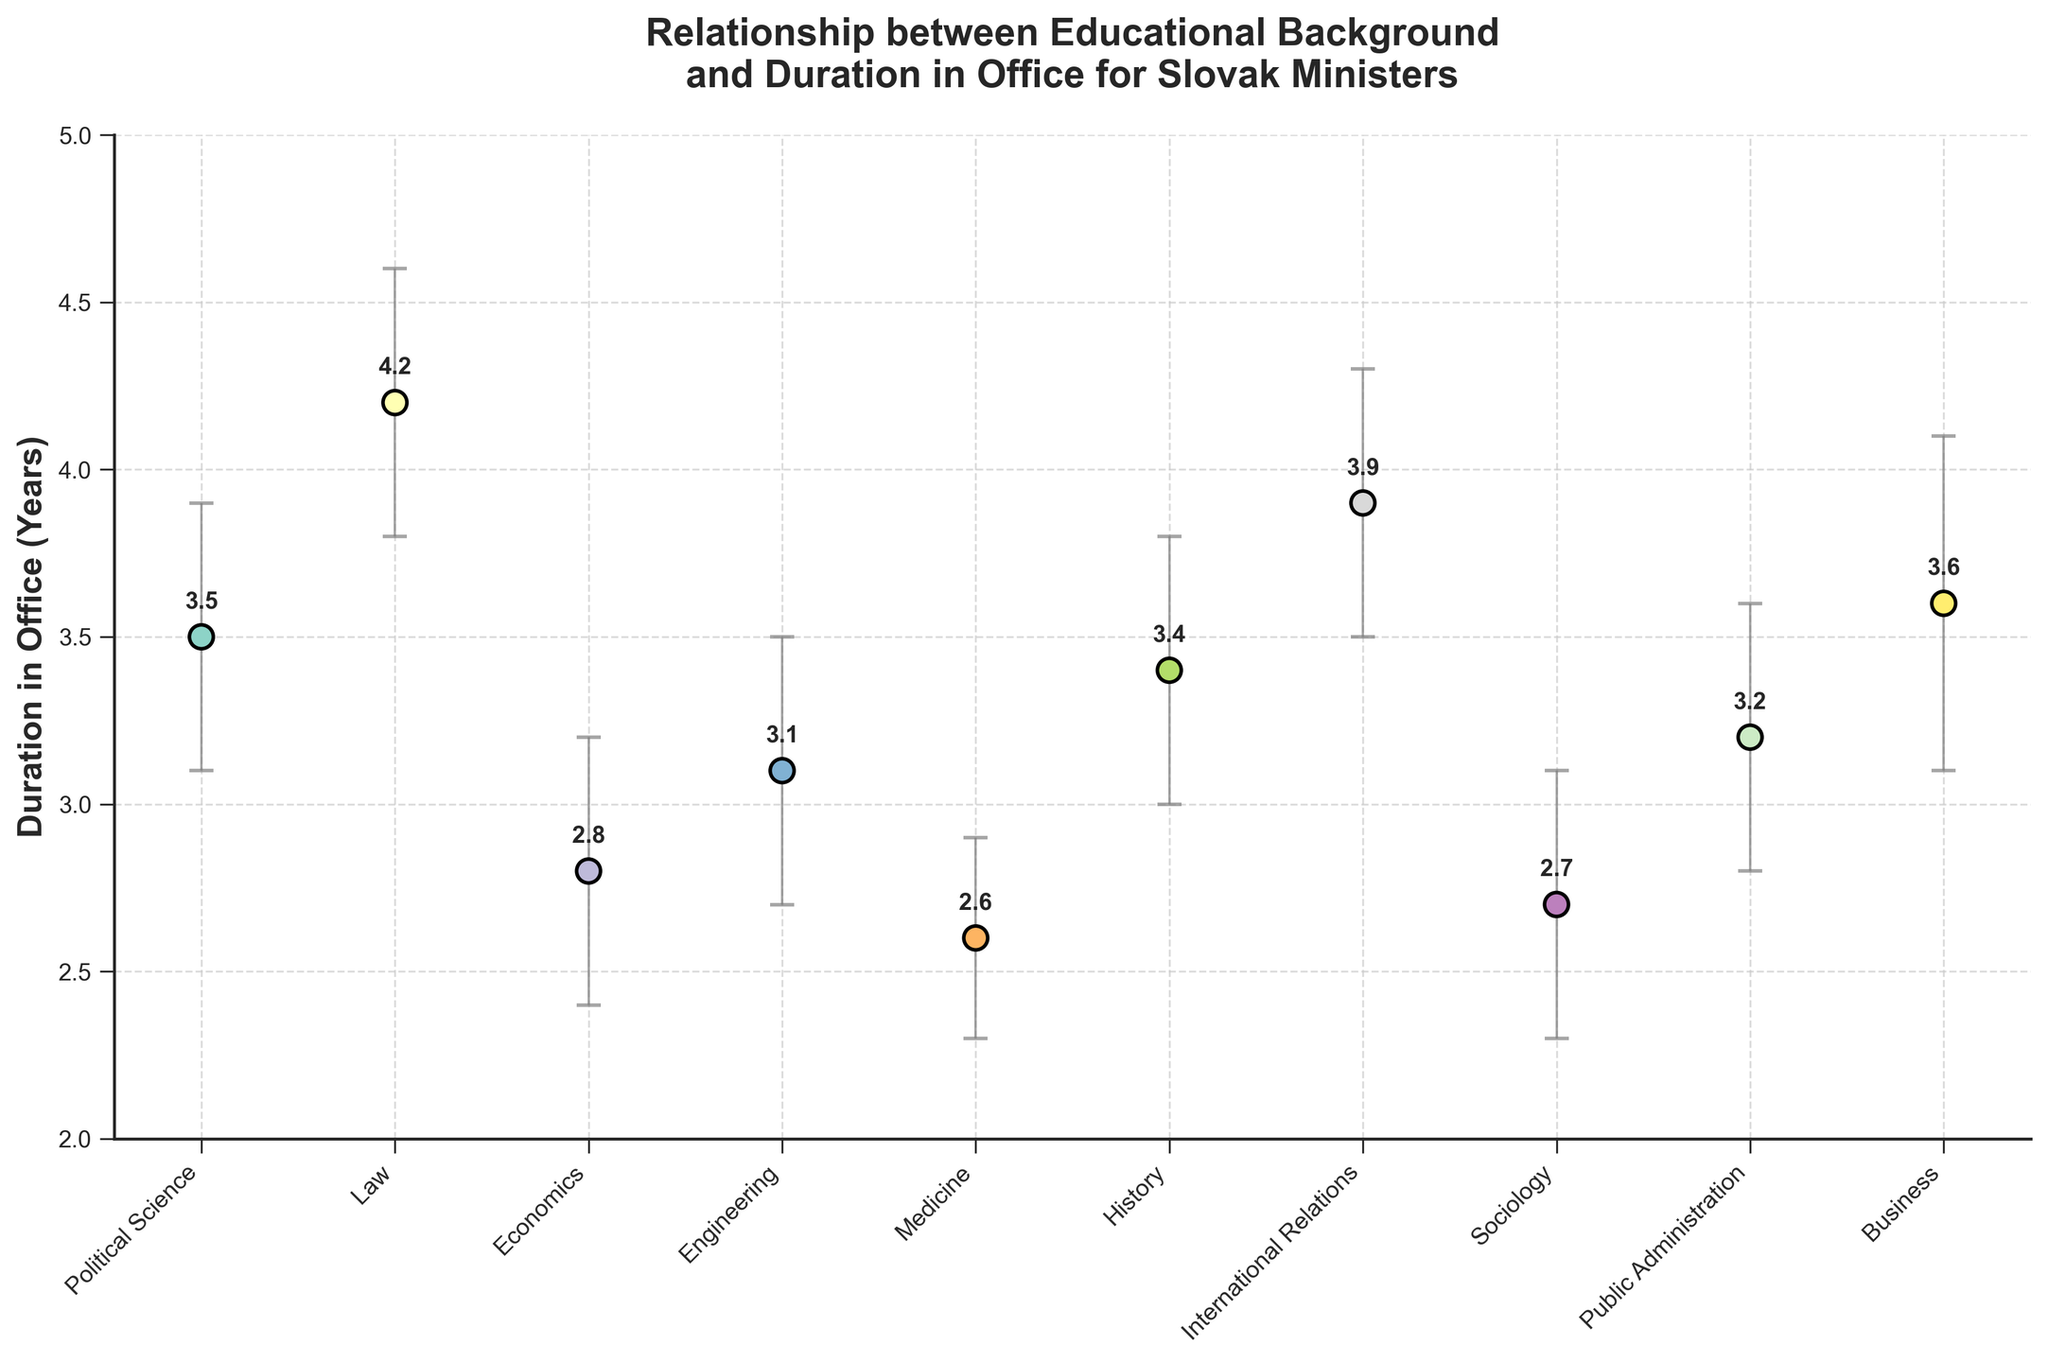What's the title of the plot? Look at the top of the plot which usually contains the title.
Answer: Relationship between Educational Background and Duration in Office for Slovak Ministers How many educational categories are presented in the plot? Count the distinct educational backgrounds listed along the x-axis.
Answer: 10 Which educational background category has the longest average duration in office? Look for the highest point on the y-axis among the data points.
Answer: Law What is the duration in office for ministers with a background in Medicine? Locate the data point labeled "Medicine" on the x-axis and read its corresponding y-value.
Answer: 2.6 years Compare the duration in office for "Political Science" and "International Relations." Which one is higher? Find the data points for both categories and compare their positions on the y-axis.
Answer: International Relations What is the confidence interval for the duration in office of ministers with a background in Economics? Look at the error bars associated with the "Economics" data point; read the lower and upper bounds of the error bars.
Answer: 2.4 to 3.2 years Which educational category has the smallest confidence interval range? Calculate the range for each category by subtracting the lower bound from the upper bound of the confidence intervals, then find the smallest value.
Answer: Medicine What is the difference in the duration in office between ministers with a background in Business and Sociology? Subtract the duration value for Sociology from the duration value for Business.
Answer: 3.6 - 2.7 = 0.9 years Arrange the educational categories in ascending order of their average duration in office. List all the categories and sort them based on their corresponding y-values from lowest to highest.
Answer: Medicine, Sociology, Economics, Engineering, Public Administration, History, Political Science, Business, International Relations, Law What is the average duration in office for all the educational categories combined? Add up all the average durations and divide by the total number of categories.
Answer: (3.5 + 4.2 + 2.8 + 3.1 + 2.6 + 3.4 + 3.9 + 2.7 + 3.2 + 3.6) ÷ 10 = 3.3 years 